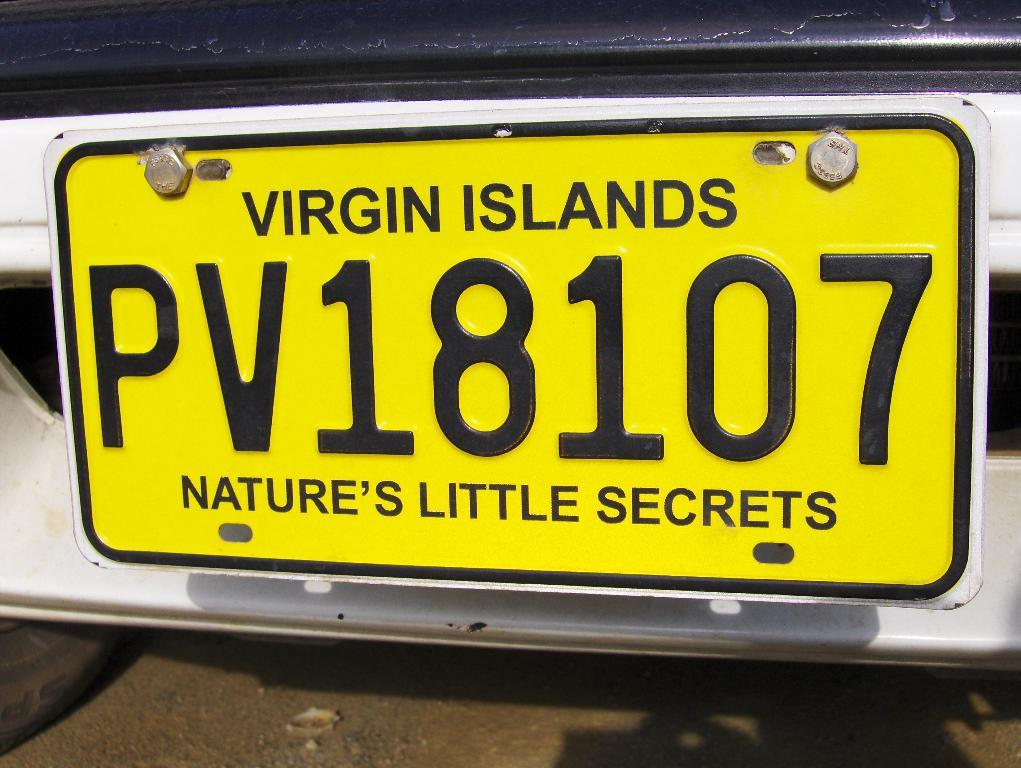<image>
Share a concise interpretation of the image provided. A yellow license plate with black lettering for the VIrgin Islands. 